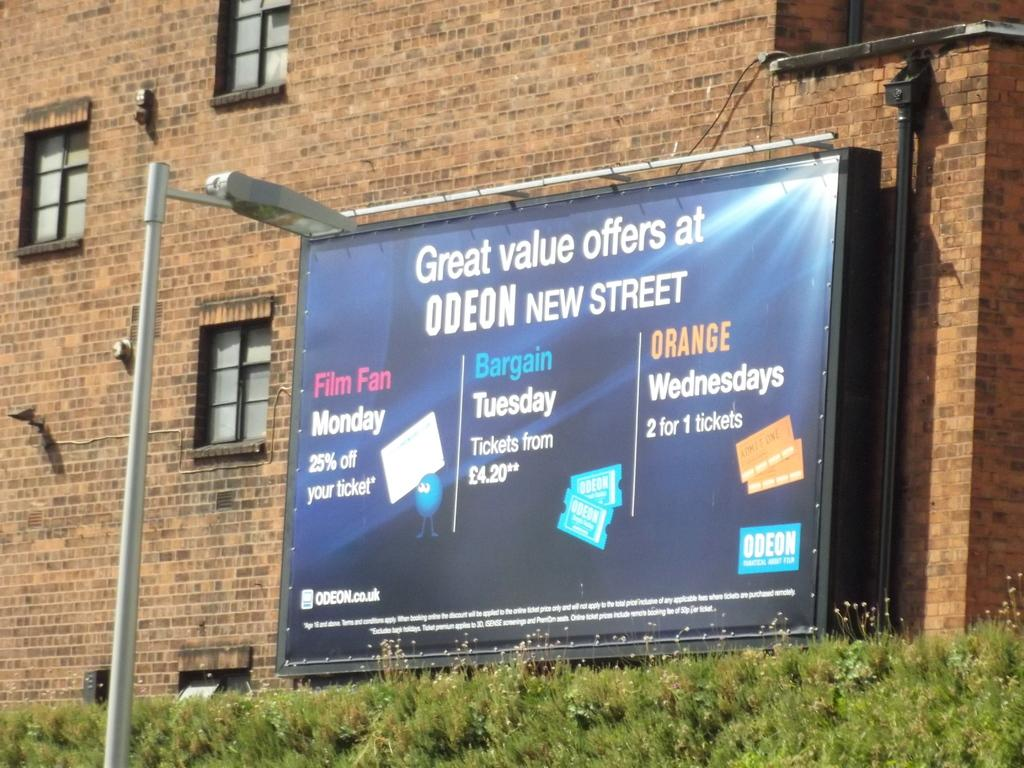<image>
Offer a succinct explanation of the picture presented. A banner that's offering ads at Odeon New Street. 